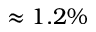<formula> <loc_0><loc_0><loc_500><loc_500>\approx 1 . 2 \%</formula> 